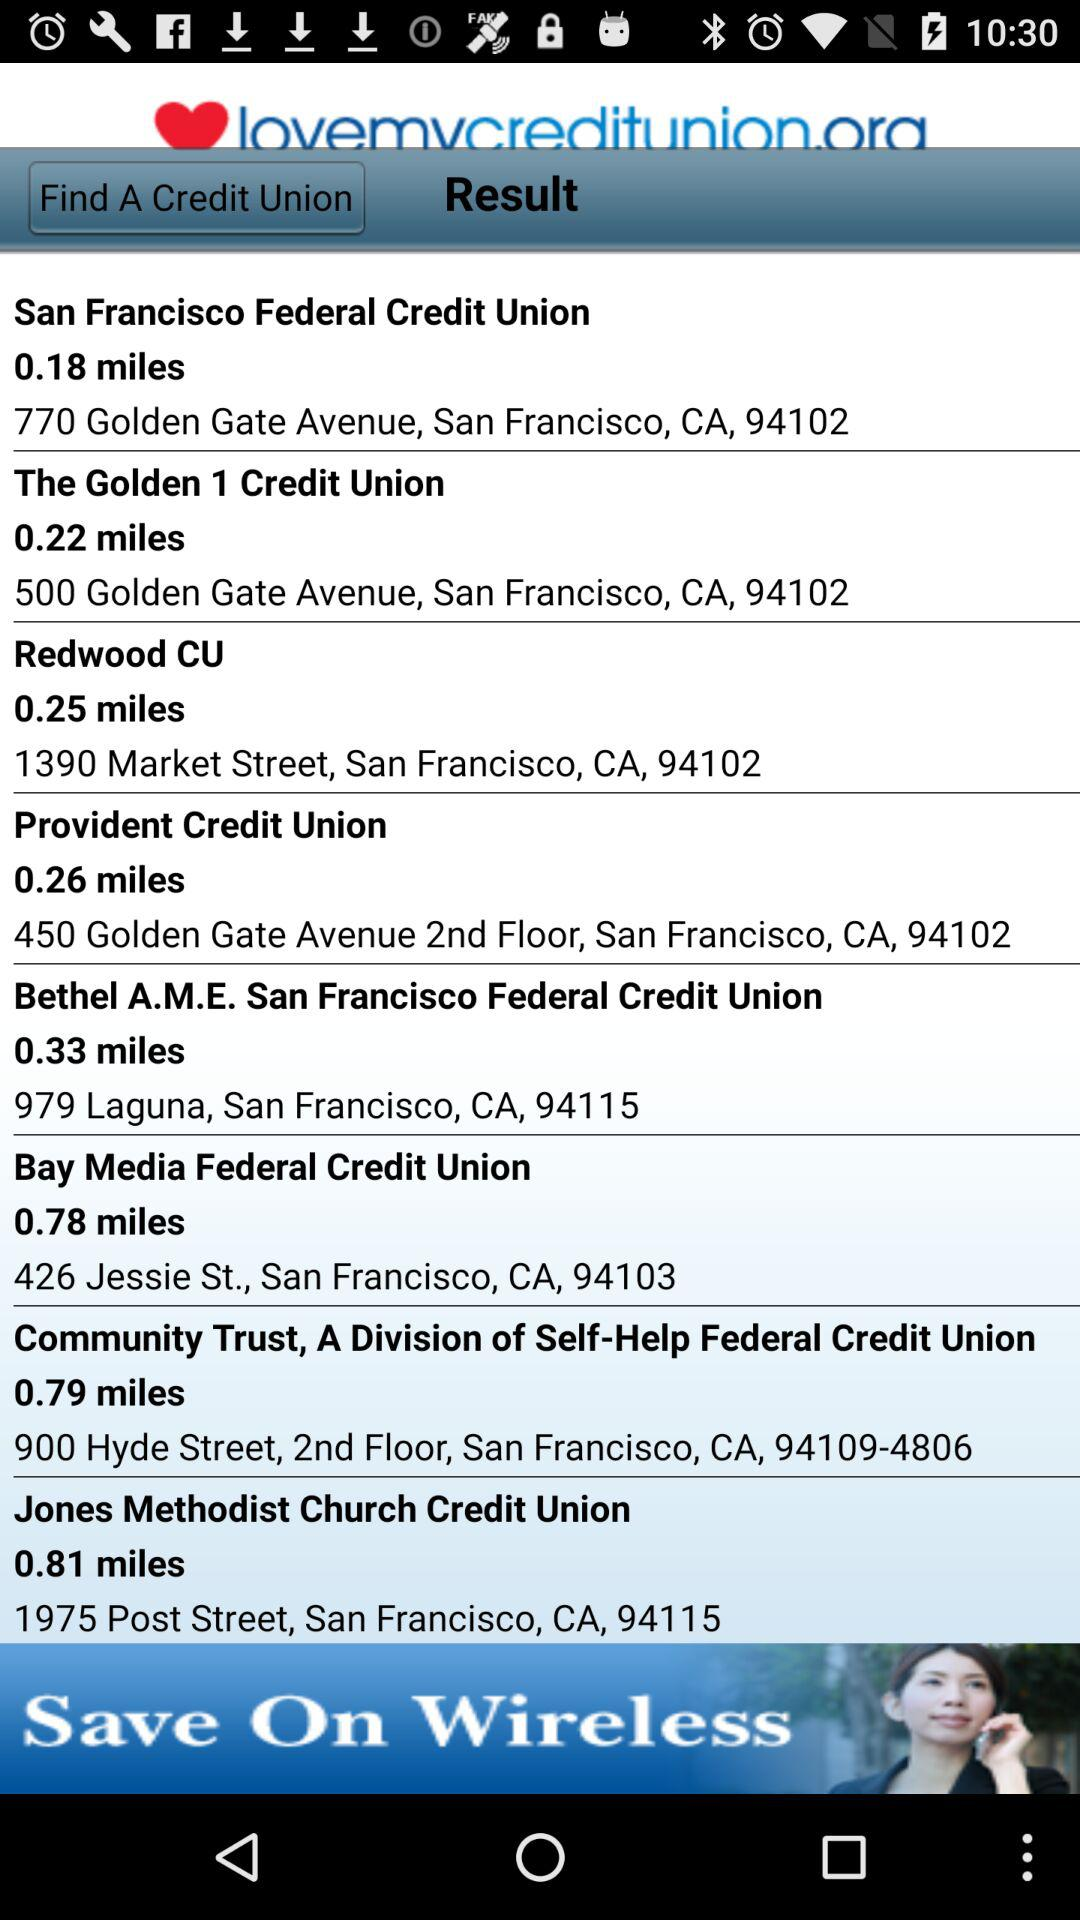Which credit union is 0.79 miles away? The credit union that is 0.79 miles away is "Community Trust, A Division of Self-Help Federal Credit Union". 